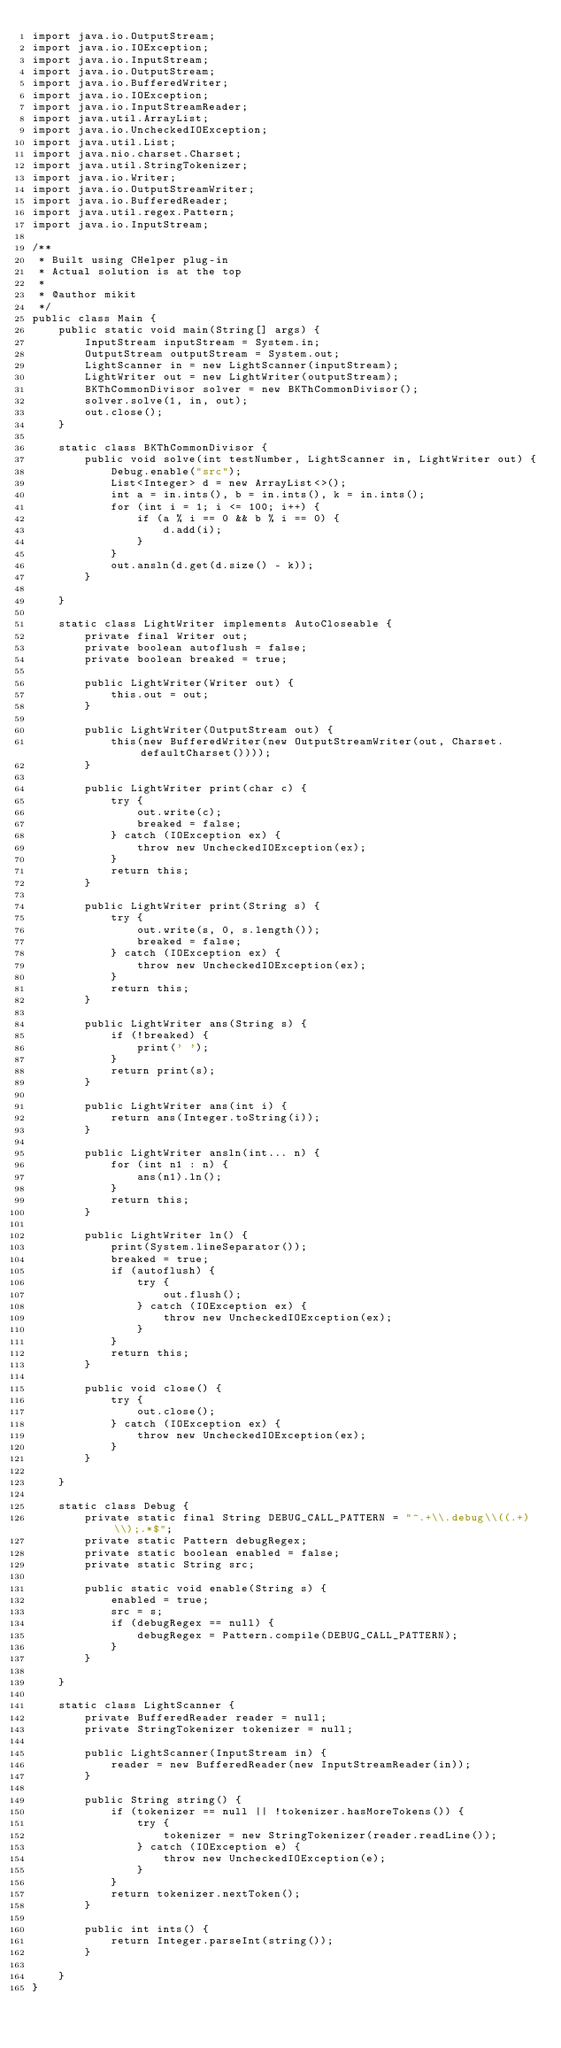Convert code to text. <code><loc_0><loc_0><loc_500><loc_500><_Java_>import java.io.OutputStream;
import java.io.IOException;
import java.io.InputStream;
import java.io.OutputStream;
import java.io.BufferedWriter;
import java.io.IOException;
import java.io.InputStreamReader;
import java.util.ArrayList;
import java.io.UncheckedIOException;
import java.util.List;
import java.nio.charset.Charset;
import java.util.StringTokenizer;
import java.io.Writer;
import java.io.OutputStreamWriter;
import java.io.BufferedReader;
import java.util.regex.Pattern;
import java.io.InputStream;

/**
 * Built using CHelper plug-in
 * Actual solution is at the top
 *
 * @author mikit
 */
public class Main {
    public static void main(String[] args) {
        InputStream inputStream = System.in;
        OutputStream outputStream = System.out;
        LightScanner in = new LightScanner(inputStream);
        LightWriter out = new LightWriter(outputStream);
        BKThCommonDivisor solver = new BKThCommonDivisor();
        solver.solve(1, in, out);
        out.close();
    }

    static class BKThCommonDivisor {
        public void solve(int testNumber, LightScanner in, LightWriter out) {
            Debug.enable("src");
            List<Integer> d = new ArrayList<>();
            int a = in.ints(), b = in.ints(), k = in.ints();
            for (int i = 1; i <= 100; i++) {
                if (a % i == 0 && b % i == 0) {
                    d.add(i);
                }
            }
            out.ansln(d.get(d.size() - k));
        }

    }

    static class LightWriter implements AutoCloseable {
        private final Writer out;
        private boolean autoflush = false;
        private boolean breaked = true;

        public LightWriter(Writer out) {
            this.out = out;
        }

        public LightWriter(OutputStream out) {
            this(new BufferedWriter(new OutputStreamWriter(out, Charset.defaultCharset())));
        }

        public LightWriter print(char c) {
            try {
                out.write(c);
                breaked = false;
            } catch (IOException ex) {
                throw new UncheckedIOException(ex);
            }
            return this;
        }

        public LightWriter print(String s) {
            try {
                out.write(s, 0, s.length());
                breaked = false;
            } catch (IOException ex) {
                throw new UncheckedIOException(ex);
            }
            return this;
        }

        public LightWriter ans(String s) {
            if (!breaked) {
                print(' ');
            }
            return print(s);
        }

        public LightWriter ans(int i) {
            return ans(Integer.toString(i));
        }

        public LightWriter ansln(int... n) {
            for (int n1 : n) {
                ans(n1).ln();
            }
            return this;
        }

        public LightWriter ln() {
            print(System.lineSeparator());
            breaked = true;
            if (autoflush) {
                try {
                    out.flush();
                } catch (IOException ex) {
                    throw new UncheckedIOException(ex);
                }
            }
            return this;
        }

        public void close() {
            try {
                out.close();
            } catch (IOException ex) {
                throw new UncheckedIOException(ex);
            }
        }

    }

    static class Debug {
        private static final String DEBUG_CALL_PATTERN = "^.+\\.debug\\((.+)\\);.*$";
        private static Pattern debugRegex;
        private static boolean enabled = false;
        private static String src;

        public static void enable(String s) {
            enabled = true;
            src = s;
            if (debugRegex == null) {
                debugRegex = Pattern.compile(DEBUG_CALL_PATTERN);
            }
        }

    }

    static class LightScanner {
        private BufferedReader reader = null;
        private StringTokenizer tokenizer = null;

        public LightScanner(InputStream in) {
            reader = new BufferedReader(new InputStreamReader(in));
        }

        public String string() {
            if (tokenizer == null || !tokenizer.hasMoreTokens()) {
                try {
                    tokenizer = new StringTokenizer(reader.readLine());
                } catch (IOException e) {
                    throw new UncheckedIOException(e);
                }
            }
            return tokenizer.nextToken();
        }

        public int ints() {
            return Integer.parseInt(string());
        }

    }
}

</code> 